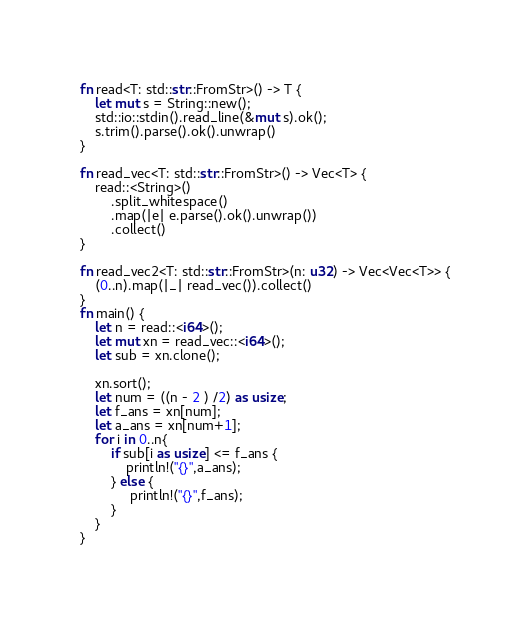Convert code to text. <code><loc_0><loc_0><loc_500><loc_500><_Rust_>
fn read<T: std::str::FromStr>() -> T {
    let mut s = String::new();
    std::io::stdin().read_line(&mut s).ok();
    s.trim().parse().ok().unwrap()
}

fn read_vec<T: std::str::FromStr>() -> Vec<T> {
    read::<String>()
        .split_whitespace()
        .map(|e| e.parse().ok().unwrap())
        .collect()
}

fn read_vec2<T: std::str::FromStr>(n: u32) -> Vec<Vec<T>> {
    (0..n).map(|_| read_vec()).collect()
}
fn main() {
    let n = read::<i64>();
    let mut xn = read_vec::<i64>();
    let sub = xn.clone();

    xn.sort();
    let num = ((n - 2 ) /2) as usize;
    let f_ans = xn[num];
    let a_ans = xn[num+1];
    for i in 0..n{
        if sub[i as usize] <= f_ans {
            println!("{}",a_ans);
        } else {
             println!("{}",f_ans);
        }
    }
}</code> 